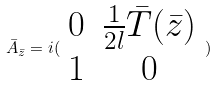<formula> <loc_0><loc_0><loc_500><loc_500>\bar { A } _ { \bar { z } } = i ( \begin{array} { c c } 0 & \frac { 1 } { 2 l } \bar { T } ( \bar { z } ) \\ 1 & 0 \end{array} )</formula> 